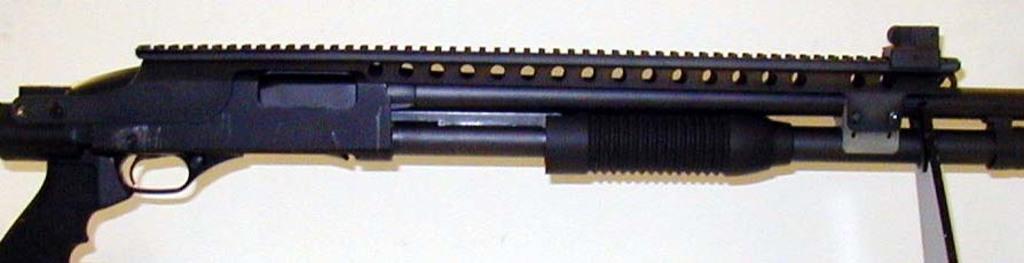Could you give a brief overview of what you see in this image? There is a weapon in the image. 